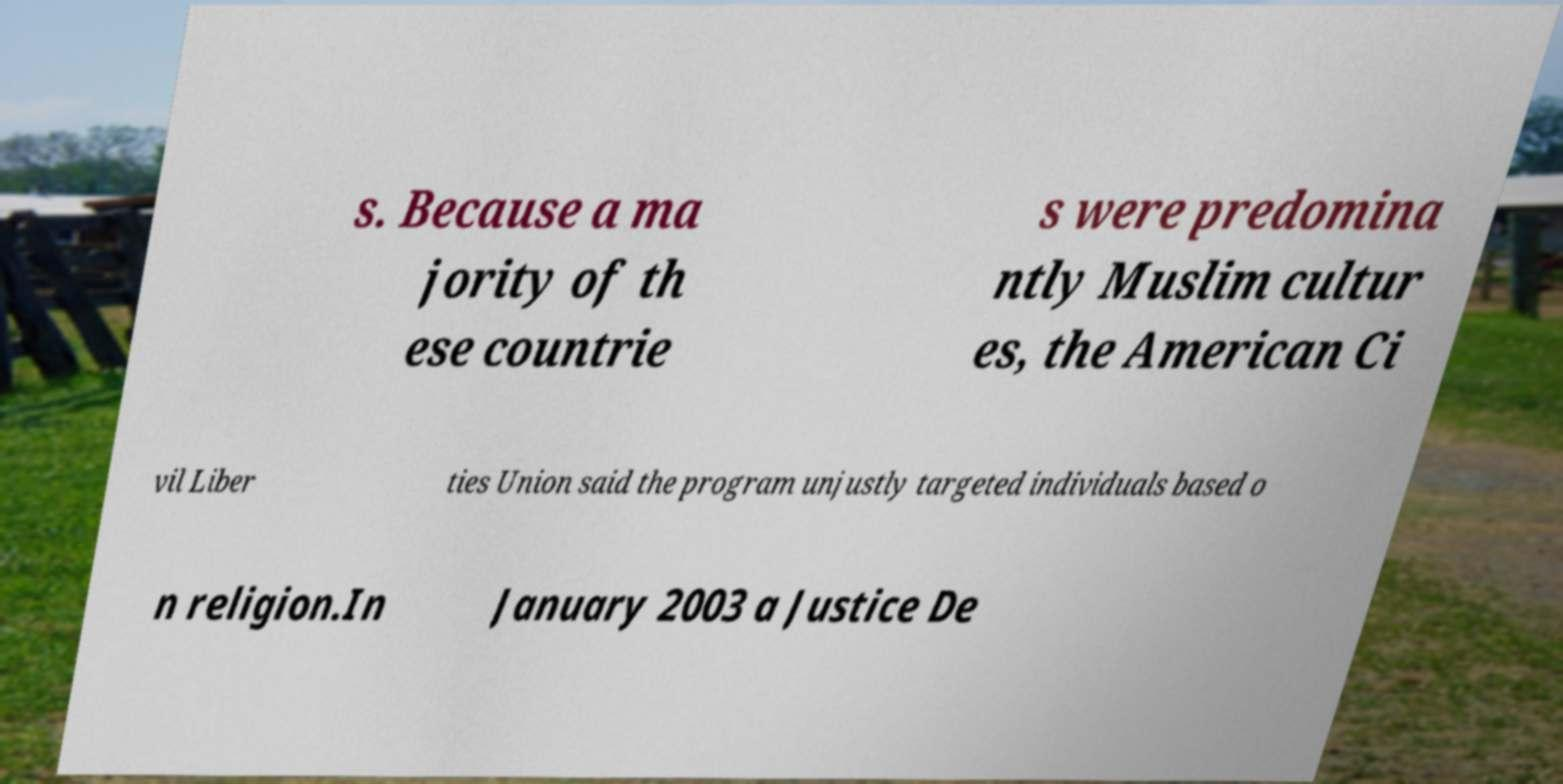Please identify and transcribe the text found in this image. s. Because a ma jority of th ese countrie s were predomina ntly Muslim cultur es, the American Ci vil Liber ties Union said the program unjustly targeted individuals based o n religion.In January 2003 a Justice De 